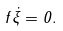<formula> <loc_0><loc_0><loc_500><loc_500>f \dot { \xi } = 0 .</formula> 